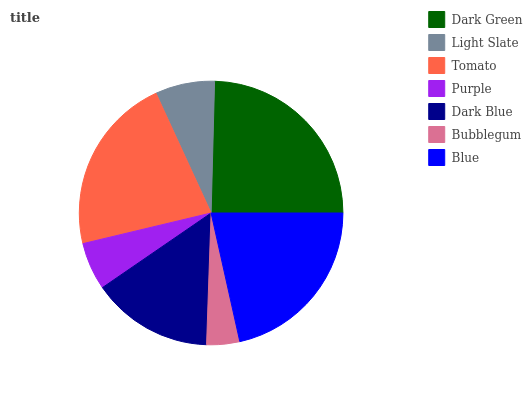Is Bubblegum the minimum?
Answer yes or no. Yes. Is Dark Green the maximum?
Answer yes or no. Yes. Is Light Slate the minimum?
Answer yes or no. No. Is Light Slate the maximum?
Answer yes or no. No. Is Dark Green greater than Light Slate?
Answer yes or no. Yes. Is Light Slate less than Dark Green?
Answer yes or no. Yes. Is Light Slate greater than Dark Green?
Answer yes or no. No. Is Dark Green less than Light Slate?
Answer yes or no. No. Is Dark Blue the high median?
Answer yes or no. Yes. Is Dark Blue the low median?
Answer yes or no. Yes. Is Light Slate the high median?
Answer yes or no. No. Is Bubblegum the low median?
Answer yes or no. No. 